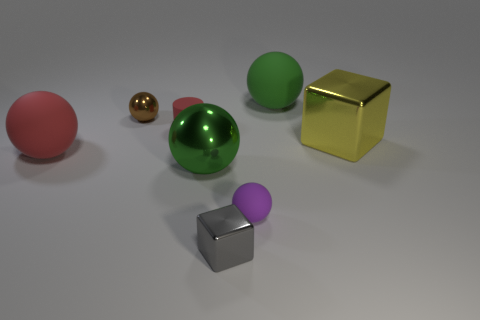What number of other objects are there of the same size as the brown metallic ball?
Offer a terse response. 3. There is another matte object that is the same size as the purple object; what color is it?
Make the answer very short. Red. Is there anything else that is the same color as the small rubber sphere?
Provide a succinct answer. No. What is the size of the red thing that is behind the cube that is behind the shiny thing in front of the purple rubber ball?
Keep it short and to the point. Small. There is a thing that is on the left side of the tiny gray shiny object and behind the small cylinder; what is its color?
Provide a short and direct response. Brown. There is a green object that is on the right side of the small purple rubber ball; how big is it?
Make the answer very short. Large. How many balls have the same material as the gray thing?
Keep it short and to the point. 2. The thing that is the same color as the tiny matte cylinder is what shape?
Make the answer very short. Sphere. There is a green thing in front of the small brown sphere; is its shape the same as the gray shiny thing?
Your answer should be compact. No. There is a small object that is made of the same material as the tiny purple sphere; what is its color?
Make the answer very short. Red. 